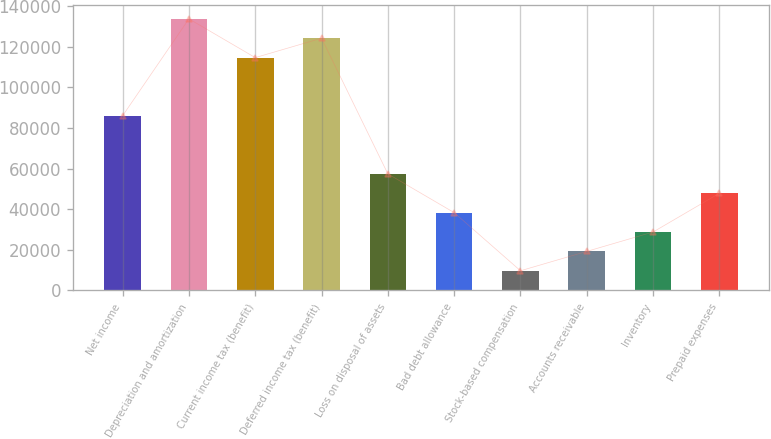<chart> <loc_0><loc_0><loc_500><loc_500><bar_chart><fcel>Net income<fcel>Depreciation and amortization<fcel>Current income tax (benefit)<fcel>Deferred income tax (benefit)<fcel>Loss on disposal of assets<fcel>Bad debt allowance<fcel>Stock-based compensation<fcel>Accounts receivable<fcel>Inventory<fcel>Prepaid expenses<nl><fcel>86068<fcel>133803<fcel>114709<fcel>124256<fcel>57427<fcel>38333<fcel>9692<fcel>19239<fcel>28786<fcel>47880<nl></chart> 